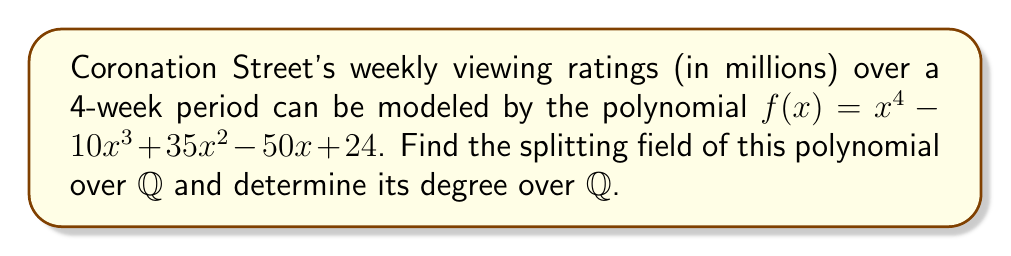Provide a solution to this math problem. 1) First, we need to factor the polynomial $f(x) = x^4 - 10x^3 + 35x^2 - 50x + 24$.

2) Using rational root theorem and synthetic division, we can find that $(x-1)$ and $(x-3)$ are factors.

3) Factoring out these linear terms:
   $f(x) = (x-1)(x-3)(x^2 - 6x + 8)$

4) The quadratic factor can be further factored:
   $f(x) = (x-1)(x-3)(x-2)(x-4)$

5) The roots of $f(x)$ are $\{1, 2, 3, 4\}$, all of which are rational numbers.

6) The splitting field of $f(x)$ over $\mathbb{Q}$ is the smallest field extension of $\mathbb{Q}$ that contains all the roots of $f(x)$.

7) Since all roots are in $\mathbb{Q}$, the splitting field is $\mathbb{Q}$ itself.

8) The degree of the splitting field over $\mathbb{Q}$ is $[\mathbb{Q} : \mathbb{Q}] = 1$.
Answer: $\mathbb{Q}$, degree 1 